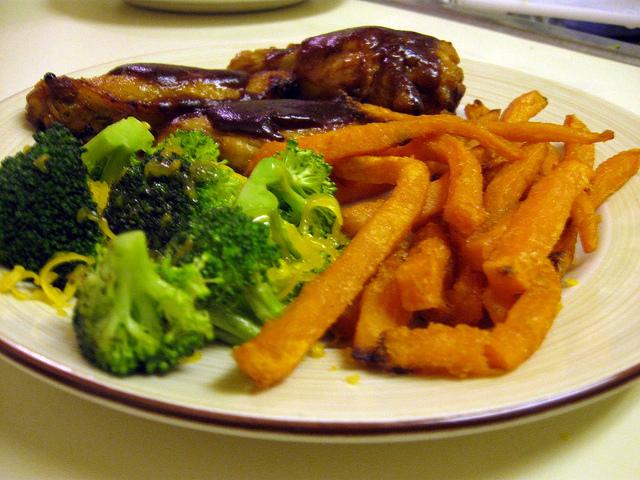Is there a slice of lime?
Be succinct. No. Is there cheese?
Answer briefly. Yes. What kind of fries are on the plate?
Concise answer only. Sweet potato. What is the food item on the right?
Answer briefly. Fries. Is this a healthy meal?
Answer briefly. Yes. How many vegetables are on the plate?
Answer briefly. 2. What is the name of this delicious looking meal?
Give a very brief answer. Dinner. 